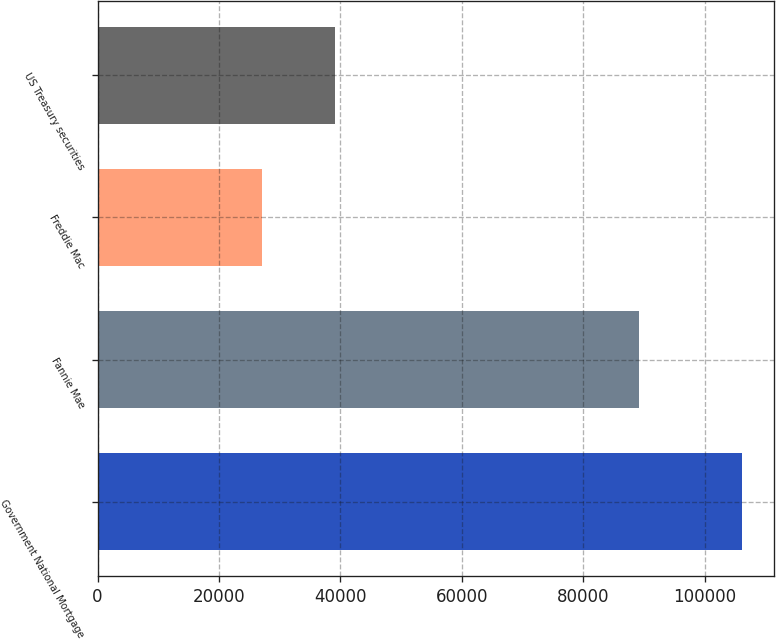Convert chart. <chart><loc_0><loc_0><loc_500><loc_500><bar_chart><fcel>Government National Mortgage<fcel>Fannie Mae<fcel>Freddie Mac<fcel>US Treasury securities<nl><fcel>106200<fcel>89243<fcel>27129<fcel>39164<nl></chart> 